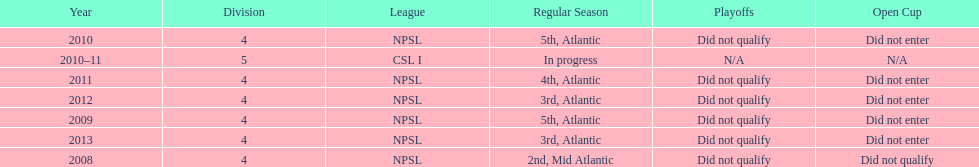Give me the full table as a dictionary. {'header': ['Year', 'Division', 'League', 'Regular Season', 'Playoffs', 'Open Cup'], 'rows': [['2010', '4', 'NPSL', '5th, Atlantic', 'Did not qualify', 'Did not enter'], ['2010–11', '5', 'CSL I', 'In progress', 'N/A', 'N/A'], ['2011', '4', 'NPSL', '4th, Atlantic', 'Did not qualify', 'Did not enter'], ['2012', '4', 'NPSL', '3rd, Atlantic', 'Did not qualify', 'Did not enter'], ['2009', '4', 'NPSL', '5th, Atlantic', 'Did not qualify', 'Did not enter'], ['2013', '4', 'NPSL', '3rd, Atlantic', 'Did not qualify', 'Did not enter'], ['2008', '4', 'NPSL', '2nd, Mid Atlantic', 'Did not qualify', 'Did not qualify']]} Using the data, what should be the next year they will play? 2014. 